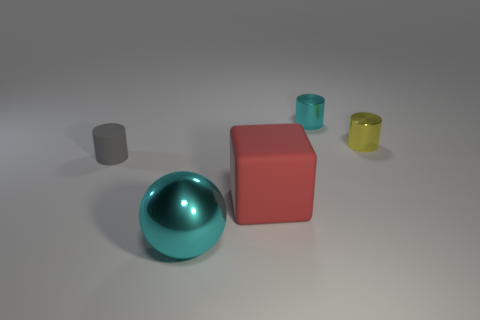Subtract all tiny yellow shiny cylinders. How many cylinders are left? 2 Add 2 cyan shiny cylinders. How many objects exist? 7 Subtract all cyan cylinders. How many cylinders are left? 2 Subtract all gray balls. How many gray cylinders are left? 1 Subtract all big brown things. Subtract all large blocks. How many objects are left? 4 Add 2 tiny things. How many tiny things are left? 5 Add 3 large cyan objects. How many large cyan objects exist? 4 Subtract 0 brown blocks. How many objects are left? 5 Subtract all balls. How many objects are left? 4 Subtract all purple balls. Subtract all yellow blocks. How many balls are left? 1 